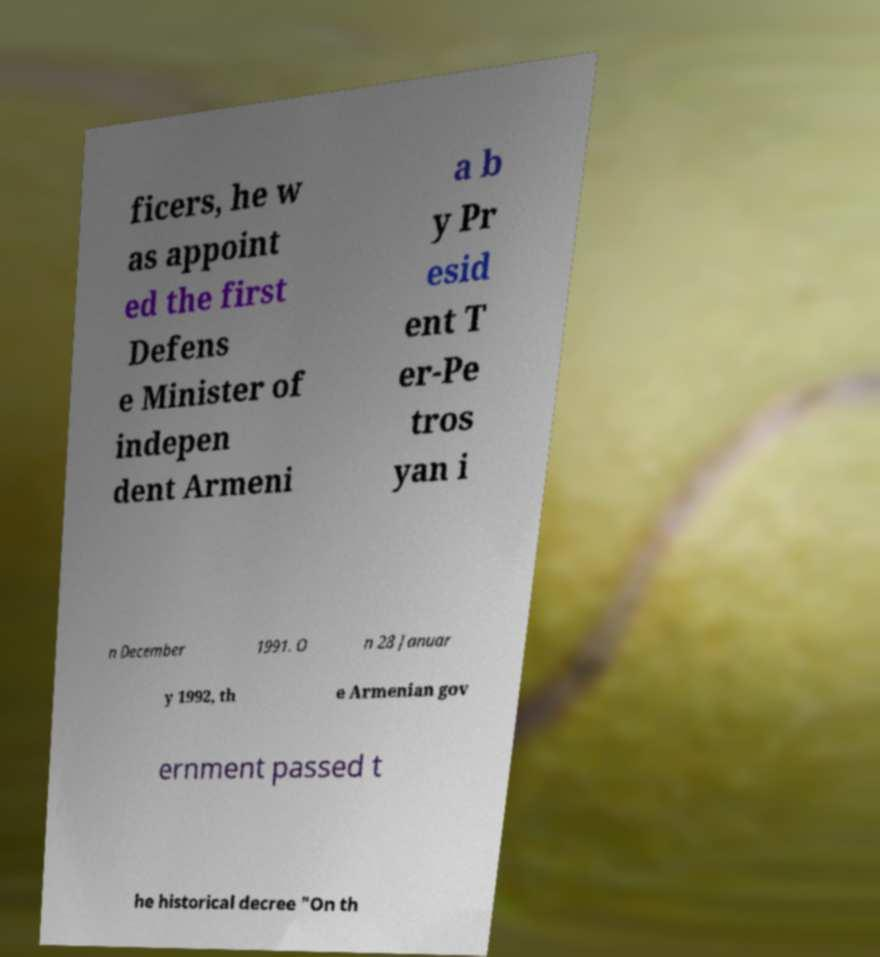I need the written content from this picture converted into text. Can you do that? ficers, he w as appoint ed the first Defens e Minister of indepen dent Armeni a b y Pr esid ent T er-Pe tros yan i n December 1991. O n 28 Januar y 1992, th e Armenian gov ernment passed t he historical decree "On th 